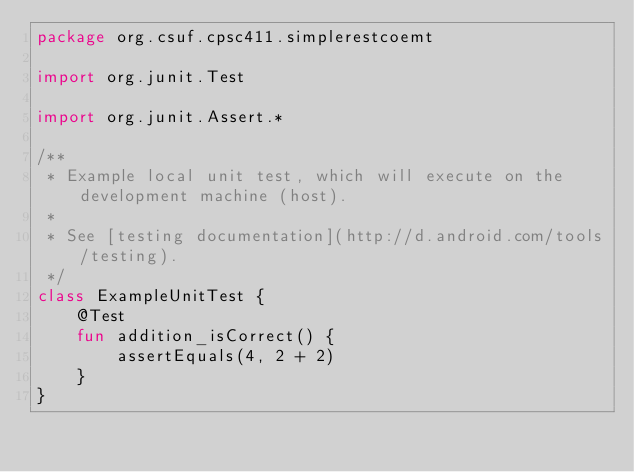Convert code to text. <code><loc_0><loc_0><loc_500><loc_500><_Kotlin_>package org.csuf.cpsc411.simplerestcoemt

import org.junit.Test

import org.junit.Assert.*

/**
 * Example local unit test, which will execute on the development machine (host).
 *
 * See [testing documentation](http://d.android.com/tools/testing).
 */
class ExampleUnitTest {
    @Test
    fun addition_isCorrect() {
        assertEquals(4, 2 + 2)
    }
}</code> 